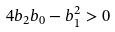Convert formula to latex. <formula><loc_0><loc_0><loc_500><loc_500>4 b _ { 2 } b _ { 0 } - b _ { 1 } ^ { 2 } > 0</formula> 